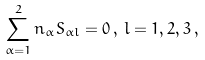Convert formula to latex. <formula><loc_0><loc_0><loc_500><loc_500>\sum _ { \alpha = 1 } ^ { 2 } n _ { \alpha } S _ { \alpha l } = 0 \, , \, l = 1 , 2 , 3 \, ,</formula> 